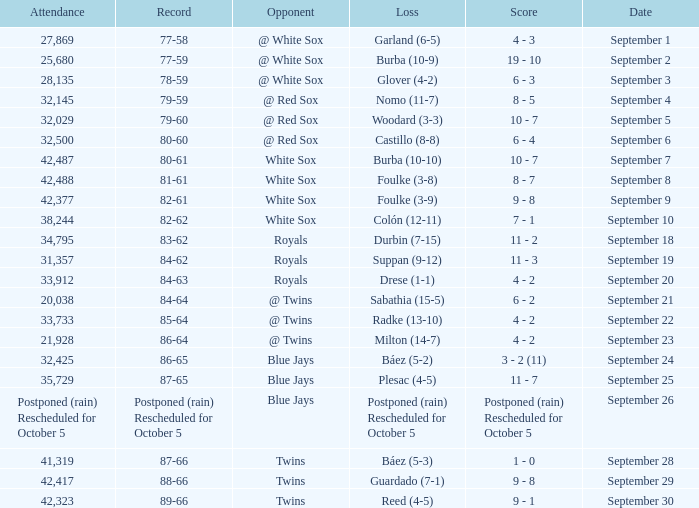What is the score of the game that holds a record of 80-61? 10 - 7. 